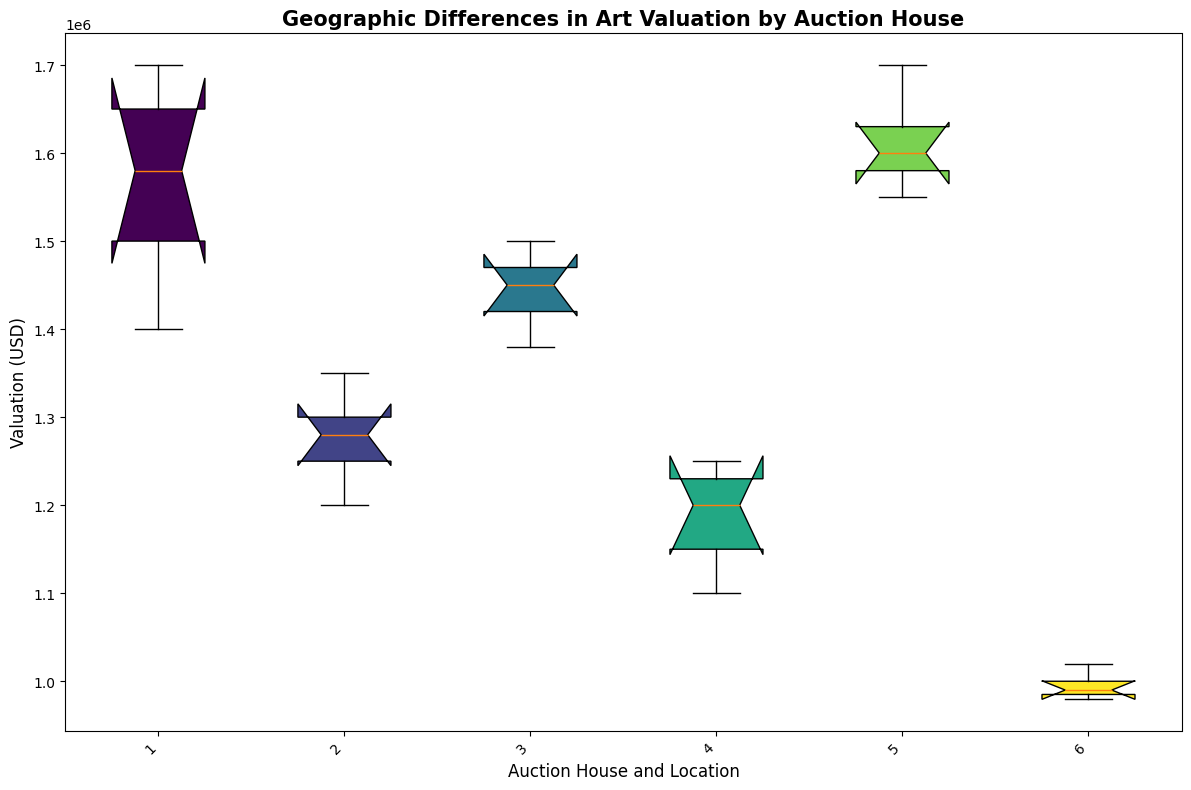What is the median valuation of Sotheby's in New York? Look at the box plot labeled "Sotheby's\nNew York" and identify the median line. The median is the line inside the box.
Answer: $1580000 Which auction house in London has the lowest average valuation? Compare the median values of the auction houses located in London from the box plot. The median line inside the box for "Christie's\nLondon" indicates it has lower valuations.
Answer: Christie's Which location has the widest range in valuations? Identify the location with the tallest box-and-whisker spread by comparing the distances between the minimum and maximum whiskers in the box plots. "Poly International\nBeijing" has the widest range.
Answer: Beijing What is the average difference in valuations between Sotheby's in New York and Bonhams in Sydney? Calculate the medians from the box plots of "Sotheby's\nNew York" ($1580000) and "Bonhams\nSydney" ($1200000), then find the difference: $1580000 - $1200000 = $380000.
Answer: $380000 Which auction house in Hong Kong has the highest valuation? Compare the upper whiskers of the auction houses located in Hong Kong in the box plot. "Phillips\nHong Kong" would show the highest valuation.
Answer: Phillips How does the valuation spread of Heffel in Vancouver compare to others? Compare the length of the box (interquartile range) and whiskers of "Heffel\nVancouver" with other auction houses. Heffel's spread is narrower and lower compared to others, indicating less variation.
Answer: Narrower Among the given auction houses, which one in Beijing has the highest median valuation? Look at the box plot labeled "Poly International\nBeijing" and identify its median line, then compare it to other locations in Beijing.
Answer: Poly International Which auction house and location have both the lowest maximum and minimum valuation? Inspect the box plots, particularly the whiskers, to find the lowest maximum and minimum values. "Heffel\nVancouver" has the lowest maximum and minimum valuations.
Answer: Heffel, Vancouver Comparing Christie's in London and Phillips in Hong Kong, which has the higher interquartile range (IQR)? Look at the boxes of "Christie's\nLondon" and "Phillips\nHong Kong". The box length represents the IQR. "Christie's\nLondon" has a slightly higher IQR (spread of the box) than "Phillips\nHong Kong".
Answer: Christie's What is the valuation difference between the upper quartile of Sotheby's in New York and the lower quartile of Bonhams in Sydney? Identify the upper quartile (top edge of the box) for "Sotheby's\nNew York" and the lower quartile (bottom edge of the box) for "Bonhams\nSydney". Calculate the difference: $1650000 - $1150000 = $500000.
Answer: $500000 